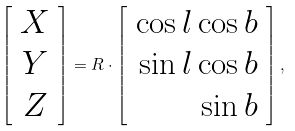<formula> <loc_0><loc_0><loc_500><loc_500>\left [ \begin{array} { c } X \\ Y \\ Z \end{array} \right ] = R \cdot \left [ \begin{array} { r } \cos l \cos b \\ \sin l \cos b \\ \sin b \end{array} \right ] ,</formula> 